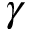Convert formula to latex. <formula><loc_0><loc_0><loc_500><loc_500>\gamma</formula> 